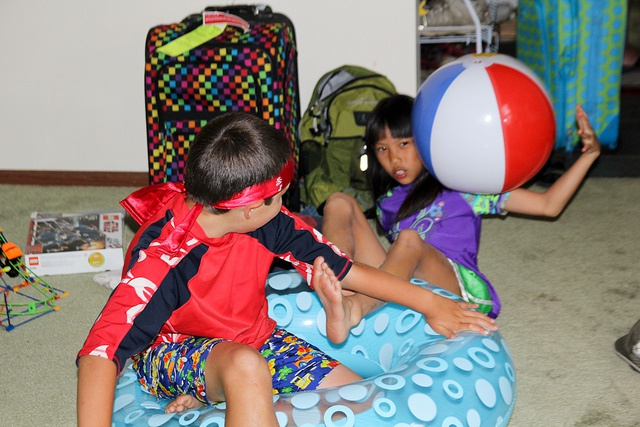Describe the objects in this image and their specific colors. I can see people in lightgray, black, red, and tan tones, people in lightgray, salmon, black, tan, and purple tones, suitcase in lightgray, black, maroon, darkgreen, and olive tones, sports ball in lightgray, lavender, red, darkgray, and brown tones, and backpack in lightgray, darkgreen, black, and gray tones in this image. 